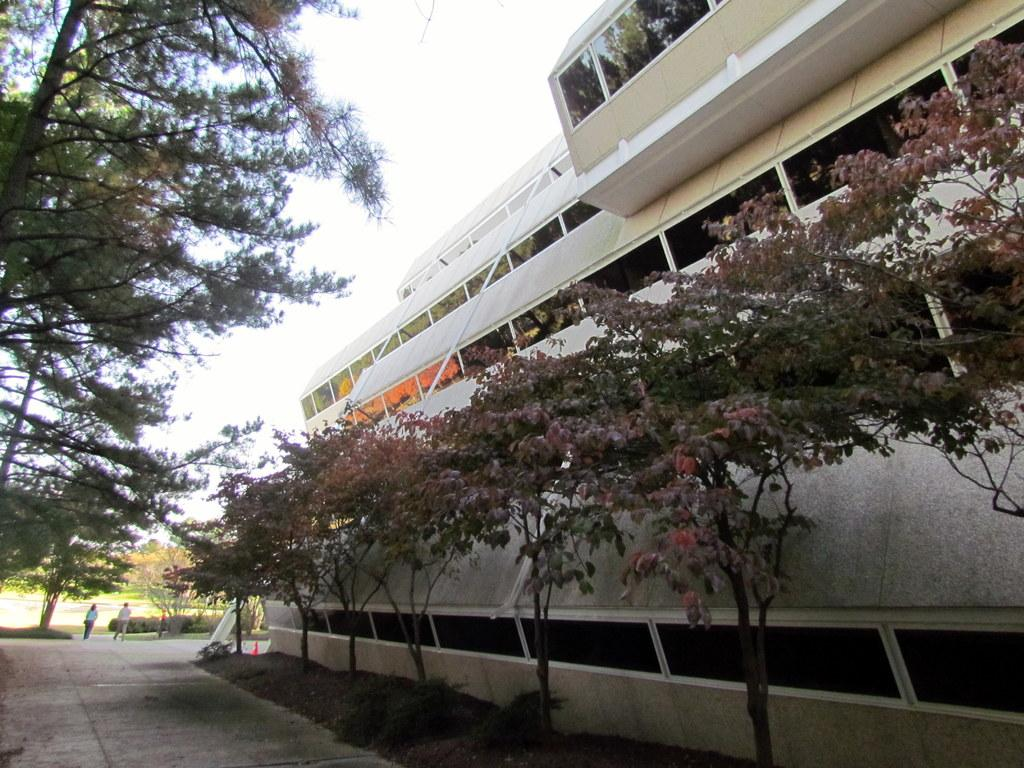What type of structure is present in the image? There is a building in the image. What can be seen in the background of the image? There are trees in the image. What is on the ground in the image? There are plants on the ground in the image. What are the people in the image doing? The people walking in the image. How would you describe the weather in the image? The sky is cloudy in the image. How many hydrants are visible in the image? There are no hydrants present in the image. What is the weight of the dock in the image? There is no dock present in the image. 